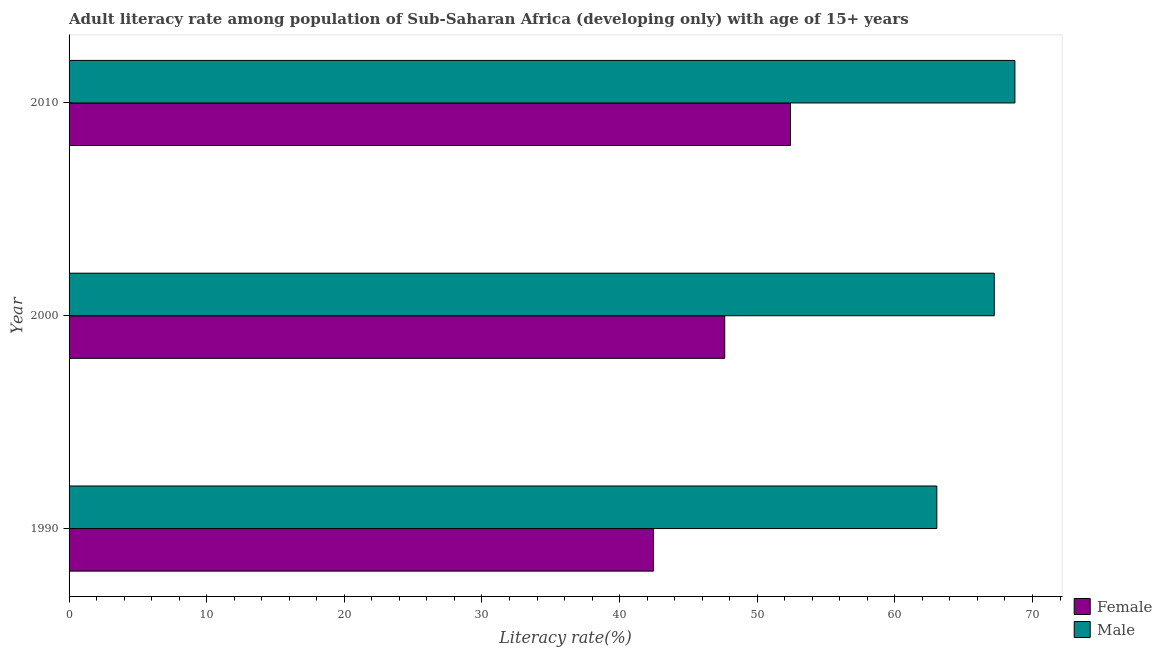How many different coloured bars are there?
Offer a very short reply. 2. How many groups of bars are there?
Make the answer very short. 3. Are the number of bars per tick equal to the number of legend labels?
Provide a succinct answer. Yes. How many bars are there on the 2nd tick from the bottom?
Offer a very short reply. 2. In how many cases, is the number of bars for a given year not equal to the number of legend labels?
Your answer should be very brief. 0. What is the female adult literacy rate in 2000?
Keep it short and to the point. 47.64. Across all years, what is the maximum female adult literacy rate?
Keep it short and to the point. 52.41. Across all years, what is the minimum male adult literacy rate?
Offer a very short reply. 63.05. In which year was the male adult literacy rate minimum?
Make the answer very short. 1990. What is the total female adult literacy rate in the graph?
Provide a short and direct response. 142.51. What is the difference between the female adult literacy rate in 1990 and that in 2010?
Give a very brief answer. -9.95. What is the difference between the male adult literacy rate in 1990 and the female adult literacy rate in 2010?
Provide a succinct answer. 10.63. What is the average female adult literacy rate per year?
Make the answer very short. 47.5. In the year 1990, what is the difference between the male adult literacy rate and female adult literacy rate?
Make the answer very short. 20.59. In how many years, is the male adult literacy rate greater than 54 %?
Offer a very short reply. 3. What is the ratio of the male adult literacy rate in 1990 to that in 2000?
Your answer should be compact. 0.94. Is the female adult literacy rate in 2000 less than that in 2010?
Give a very brief answer. Yes. Is the difference between the female adult literacy rate in 1990 and 2000 greater than the difference between the male adult literacy rate in 1990 and 2000?
Give a very brief answer. No. What is the difference between the highest and the lowest female adult literacy rate?
Provide a succinct answer. 9.95. In how many years, is the female adult literacy rate greater than the average female adult literacy rate taken over all years?
Keep it short and to the point. 2. What does the 1st bar from the bottom in 1990 represents?
Provide a short and direct response. Female. How many bars are there?
Give a very brief answer. 6. How many years are there in the graph?
Your answer should be very brief. 3. What is the difference between two consecutive major ticks on the X-axis?
Ensure brevity in your answer.  10. Are the values on the major ticks of X-axis written in scientific E-notation?
Make the answer very short. No. Where does the legend appear in the graph?
Offer a terse response. Bottom right. How are the legend labels stacked?
Ensure brevity in your answer.  Vertical. What is the title of the graph?
Provide a succinct answer. Adult literacy rate among population of Sub-Saharan Africa (developing only) with age of 15+ years. What is the label or title of the X-axis?
Offer a terse response. Literacy rate(%). What is the label or title of the Y-axis?
Offer a very short reply. Year. What is the Literacy rate(%) of Female in 1990?
Your answer should be very brief. 42.46. What is the Literacy rate(%) in Male in 1990?
Offer a very short reply. 63.05. What is the Literacy rate(%) of Female in 2000?
Provide a short and direct response. 47.64. What is the Literacy rate(%) in Male in 2000?
Keep it short and to the point. 67.22. What is the Literacy rate(%) of Female in 2010?
Keep it short and to the point. 52.41. What is the Literacy rate(%) of Male in 2010?
Your answer should be very brief. 68.72. Across all years, what is the maximum Literacy rate(%) of Female?
Your answer should be very brief. 52.41. Across all years, what is the maximum Literacy rate(%) in Male?
Give a very brief answer. 68.72. Across all years, what is the minimum Literacy rate(%) in Female?
Provide a short and direct response. 42.46. Across all years, what is the minimum Literacy rate(%) in Male?
Give a very brief answer. 63.05. What is the total Literacy rate(%) in Female in the graph?
Offer a terse response. 142.51. What is the total Literacy rate(%) in Male in the graph?
Provide a succinct answer. 198.99. What is the difference between the Literacy rate(%) of Female in 1990 and that in 2000?
Your response must be concise. -5.18. What is the difference between the Literacy rate(%) of Male in 1990 and that in 2000?
Offer a very short reply. -4.17. What is the difference between the Literacy rate(%) of Female in 1990 and that in 2010?
Keep it short and to the point. -9.95. What is the difference between the Literacy rate(%) of Male in 1990 and that in 2010?
Your answer should be compact. -5.67. What is the difference between the Literacy rate(%) of Female in 2000 and that in 2010?
Provide a short and direct response. -4.78. What is the difference between the Literacy rate(%) in Male in 2000 and that in 2010?
Offer a terse response. -1.5. What is the difference between the Literacy rate(%) in Female in 1990 and the Literacy rate(%) in Male in 2000?
Keep it short and to the point. -24.76. What is the difference between the Literacy rate(%) in Female in 1990 and the Literacy rate(%) in Male in 2010?
Make the answer very short. -26.26. What is the difference between the Literacy rate(%) in Female in 2000 and the Literacy rate(%) in Male in 2010?
Provide a succinct answer. -21.08. What is the average Literacy rate(%) of Female per year?
Your answer should be very brief. 47.5. What is the average Literacy rate(%) of Male per year?
Make the answer very short. 66.33. In the year 1990, what is the difference between the Literacy rate(%) in Female and Literacy rate(%) in Male?
Provide a short and direct response. -20.59. In the year 2000, what is the difference between the Literacy rate(%) of Female and Literacy rate(%) of Male?
Provide a short and direct response. -19.58. In the year 2010, what is the difference between the Literacy rate(%) of Female and Literacy rate(%) of Male?
Give a very brief answer. -16.31. What is the ratio of the Literacy rate(%) of Female in 1990 to that in 2000?
Your answer should be very brief. 0.89. What is the ratio of the Literacy rate(%) in Male in 1990 to that in 2000?
Your answer should be very brief. 0.94. What is the ratio of the Literacy rate(%) of Female in 1990 to that in 2010?
Ensure brevity in your answer.  0.81. What is the ratio of the Literacy rate(%) of Male in 1990 to that in 2010?
Provide a short and direct response. 0.92. What is the ratio of the Literacy rate(%) in Female in 2000 to that in 2010?
Give a very brief answer. 0.91. What is the ratio of the Literacy rate(%) in Male in 2000 to that in 2010?
Your response must be concise. 0.98. What is the difference between the highest and the second highest Literacy rate(%) of Female?
Make the answer very short. 4.78. What is the difference between the highest and the second highest Literacy rate(%) in Male?
Provide a short and direct response. 1.5. What is the difference between the highest and the lowest Literacy rate(%) of Female?
Give a very brief answer. 9.95. What is the difference between the highest and the lowest Literacy rate(%) of Male?
Provide a succinct answer. 5.67. 